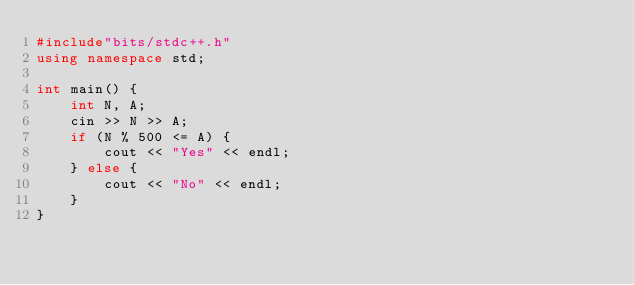<code> <loc_0><loc_0><loc_500><loc_500><_C++_>#include"bits/stdc++.h"
using namespace std;

int main() {
    int N, A;
    cin >> N >> A;
    if (N % 500 <= A) {
        cout << "Yes" << endl;
    } else {
        cout << "No" << endl;
    }
}</code> 